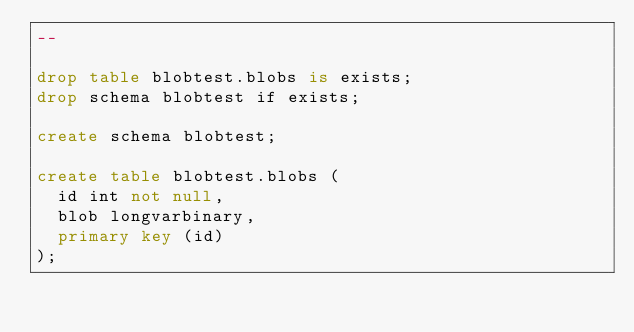<code> <loc_0><loc_0><loc_500><loc_500><_SQL_>--

drop table blobtest.blobs is exists;
drop schema blobtest if exists;

create schema blobtest;

create table blobtest.blobs (
  id int not null,
  blob longvarbinary,
  primary key (id)
);
</code> 